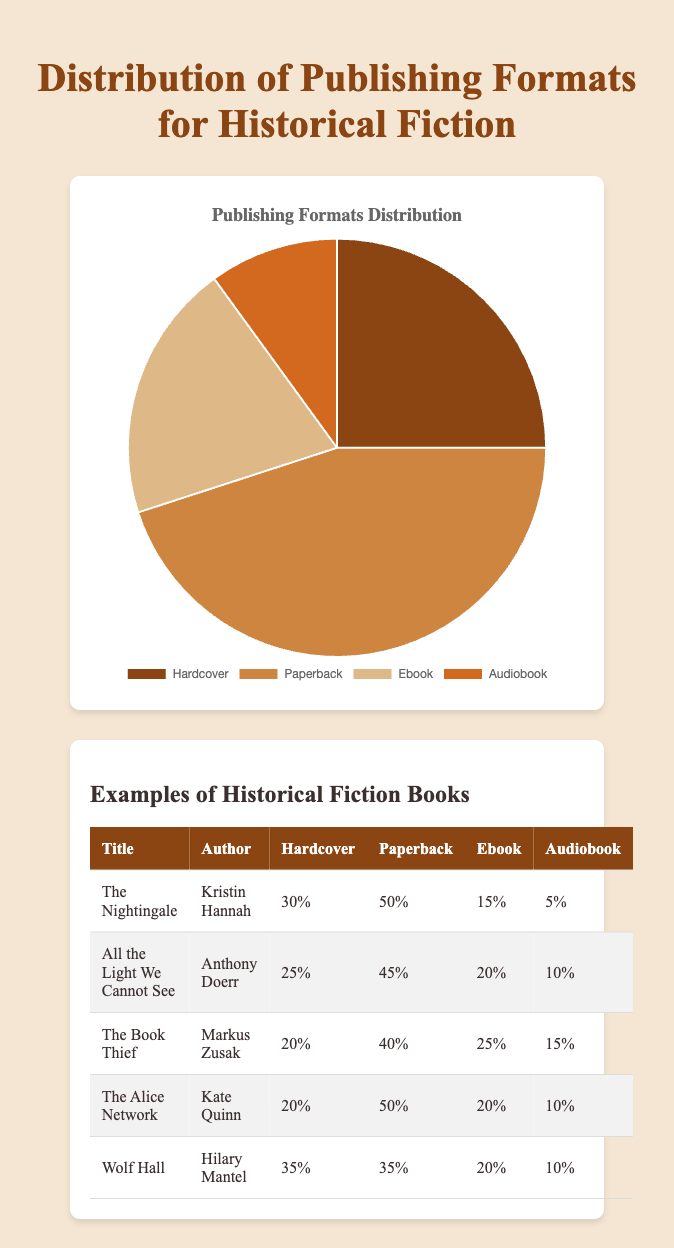What is the most common publishing format for historical fiction? The most common format can be identified by finding the largest section in the pie chart. Paperback occupies the largest section.
Answer: Paperback Which format has the smallest representation in the distribution? The smallest representation is indicated by the smallest section in the pie chart. Audiobook is the smallest.
Answer: Audiobook How much more popular are paperbacks compared to hardcovers? To find how much more popular paperbacks are compared to hardcovers, subtract the percentage of hardcovers from the percentage of paperbacks (45% - 25%).
Answer: 20% What is the combined percentage of Ebook and Audiobook formats? To get the combined percentage of Ebook and Audiobook, add their respective percentages together (20% + 10%).
Answer: 30% If the total number of historical fiction books is 200, how many of them are in the Ebook format? First, find 20% of 200 books, which gives the number of Ebook format books (200 * 0.20).
Answer: 40 Compare the sum of Hardcover and Audiobook percentages to the Paperback percentage. Is it greater or smaller? First, add the percentages of Hardcover and Audiobook formats (25% + 10%), then compare this sum (35%) with the Paperback percentage (45%).
Answer: Smaller How do the distributions of "The Book Thief" and "Wolf Hall" differ in the Audiobook format? Look at the Audiobook percentages for both titles. "The Book Thief" has 15%, while "Wolf Hall" has 10%. 15% is greater than 10%.
Answer: "The Book Thief" has a higher percentage If "All the Light We Cannot See" had an additional 5% increase in the Ebook format, what would be its new Ebook percentage? Add the 5% increase to the current Ebook percentage of "All the Light We Cannot See", which is 20% (20% + 5%).
Answer: 25% What is the average percentage of the Hardcover format across the provided examples? Sum the Hardcover percentages for all examples (30 + 25 + 20 + 20 + 35) and then divide by the number of examples (5). Average = (130 / 5).
Answer: 26% 